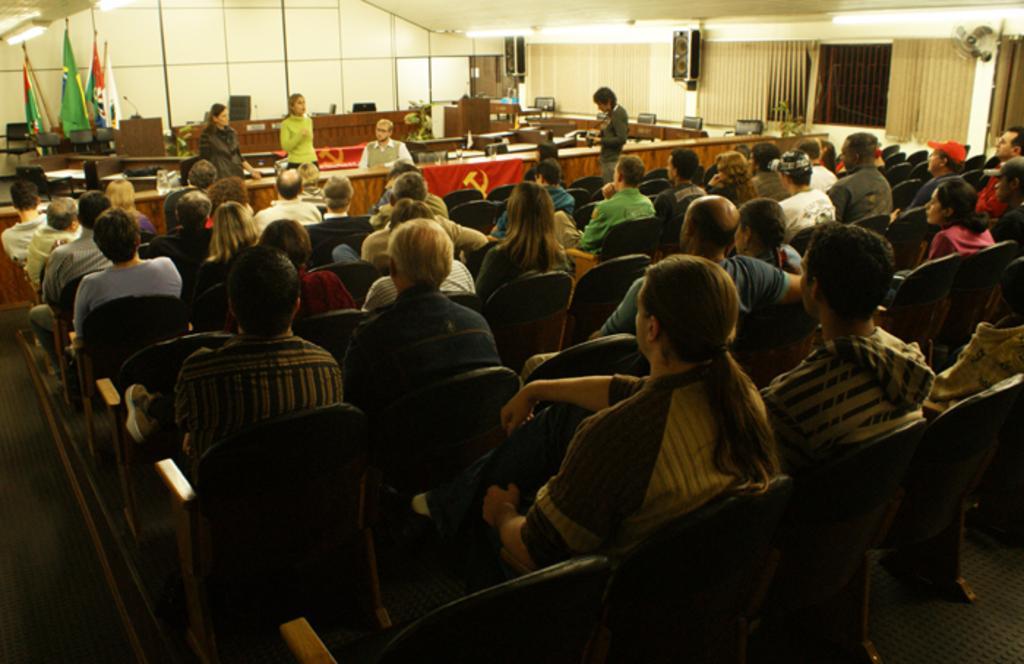Please provide a concise description of this image. In this image I can see group of people sitting, background I can see few people standing. In front the person is wearing green color shirt and I can also see few flags in multicolor, few objects on the table. I can also see few lights. 